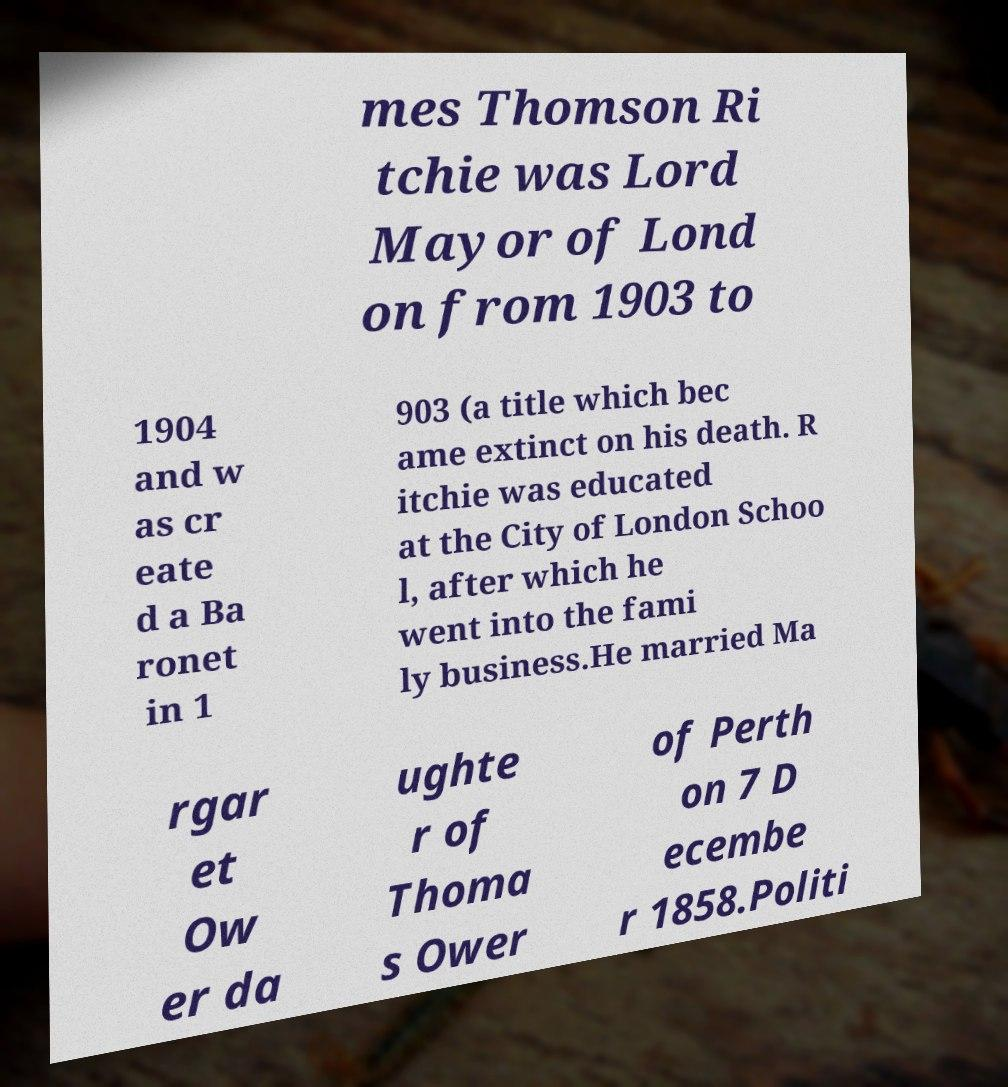I need the written content from this picture converted into text. Can you do that? mes Thomson Ri tchie was Lord Mayor of Lond on from 1903 to 1904 and w as cr eate d a Ba ronet in 1 903 (a title which bec ame extinct on his death. R itchie was educated at the City of London Schoo l, after which he went into the fami ly business.He married Ma rgar et Ow er da ughte r of Thoma s Ower of Perth on 7 D ecembe r 1858.Politi 